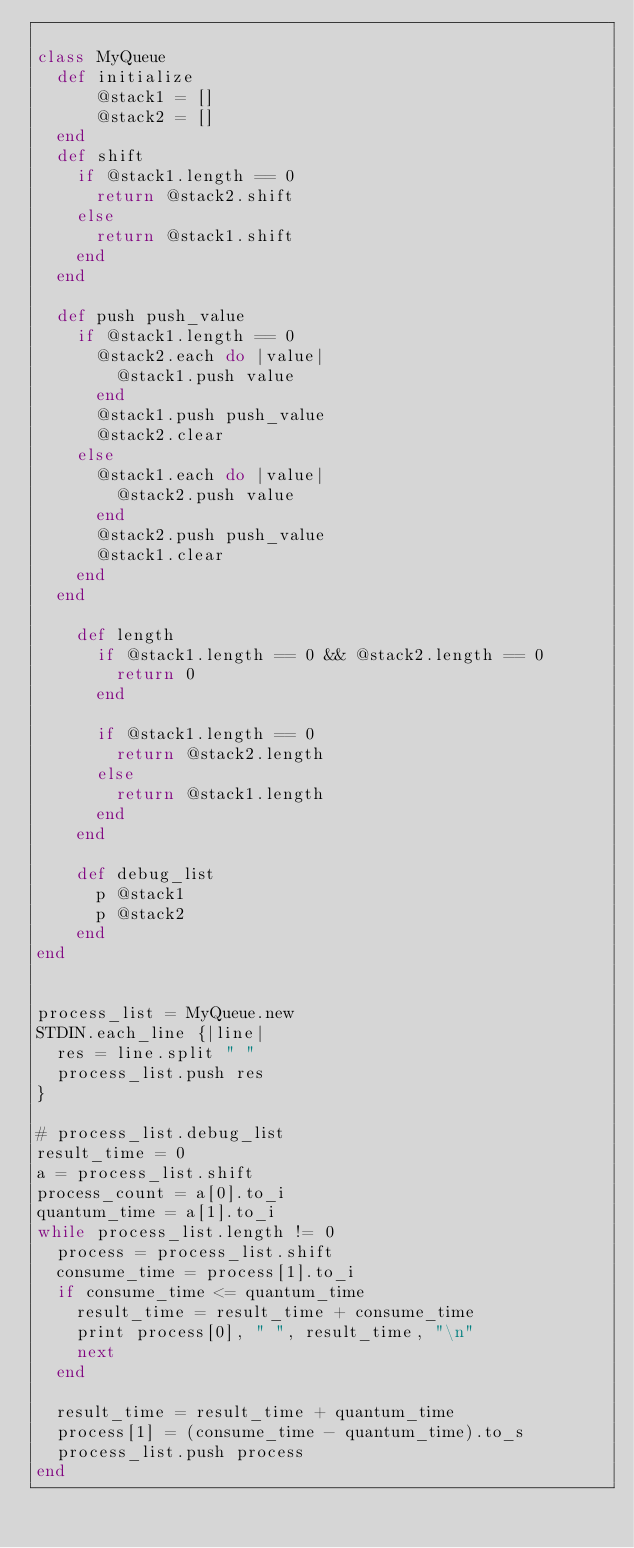<code> <loc_0><loc_0><loc_500><loc_500><_Ruby_>
class MyQueue
  def initialize
      @stack1 = []
      @stack2 = []
  end
  def shift
    if @stack1.length == 0
      return @stack2.shift
    else
      return @stack1.shift
    end
  end

  def push push_value
    if @stack1.length == 0
      @stack2.each do |value|
        @stack1.push value
      end
      @stack1.push push_value
      @stack2.clear
    else
      @stack1.each do |value|
        @stack2.push value
      end
      @stack2.push push_value
      @stack1.clear
    end
  end

    def length
      if @stack1.length == 0 && @stack2.length == 0
        return 0
      end

      if @stack1.length == 0
        return @stack2.length
      else
        return @stack1.length
      end
    end

    def debug_list
      p @stack1
      p @stack2
    end
end


process_list = MyQueue.new
STDIN.each_line {|line|
  res = line.split " "
  process_list.push res
}

# process_list.debug_list
result_time = 0
a = process_list.shift
process_count = a[0].to_i
quantum_time = a[1].to_i
while process_list.length != 0
  process = process_list.shift
  consume_time = process[1].to_i
  if consume_time <= quantum_time
    result_time = result_time + consume_time
    print process[0], " ", result_time, "\n"
    next
  end

  result_time = result_time + quantum_time
  process[1] = (consume_time - quantum_time).to_s
  process_list.push process
end

</code> 